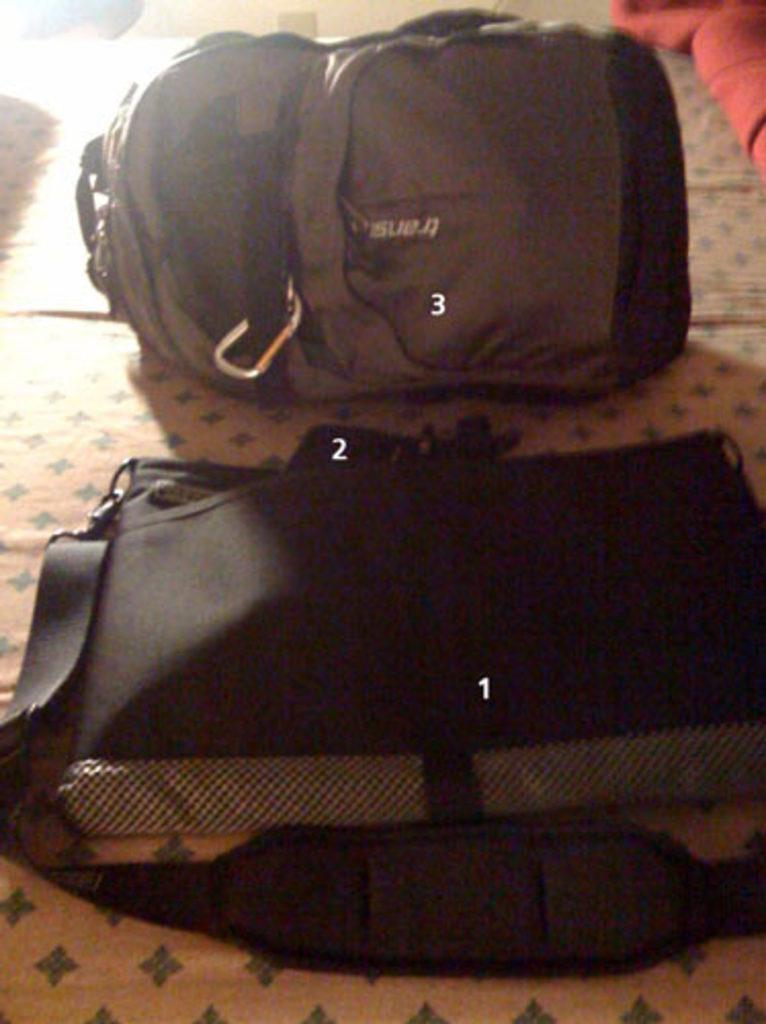What is present in the image? There is baggage in the image. Can you describe the baggage in more detail? Unfortunately, the facts provided do not give any additional details about the baggage. What might the baggage be used for? The baggage is likely being used for carrying personal belongings or items. What type of growth can be seen on the baggage in the image? There is no growth visible on the baggage in the image. Is there a vase containing a jewel on the baggage in the image? There is no vase or jewel mentioned in the provided facts, so we cannot answer this question. 